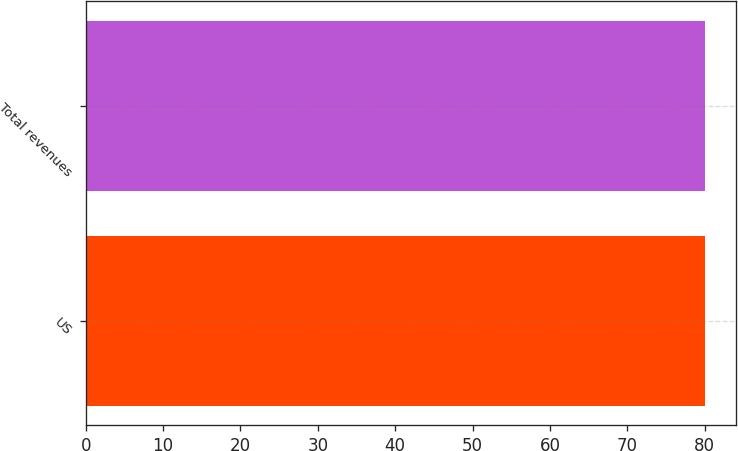Convert chart to OTSL. <chart><loc_0><loc_0><loc_500><loc_500><bar_chart><fcel>US<fcel>Total revenues<nl><fcel>80<fcel>80.1<nl></chart> 